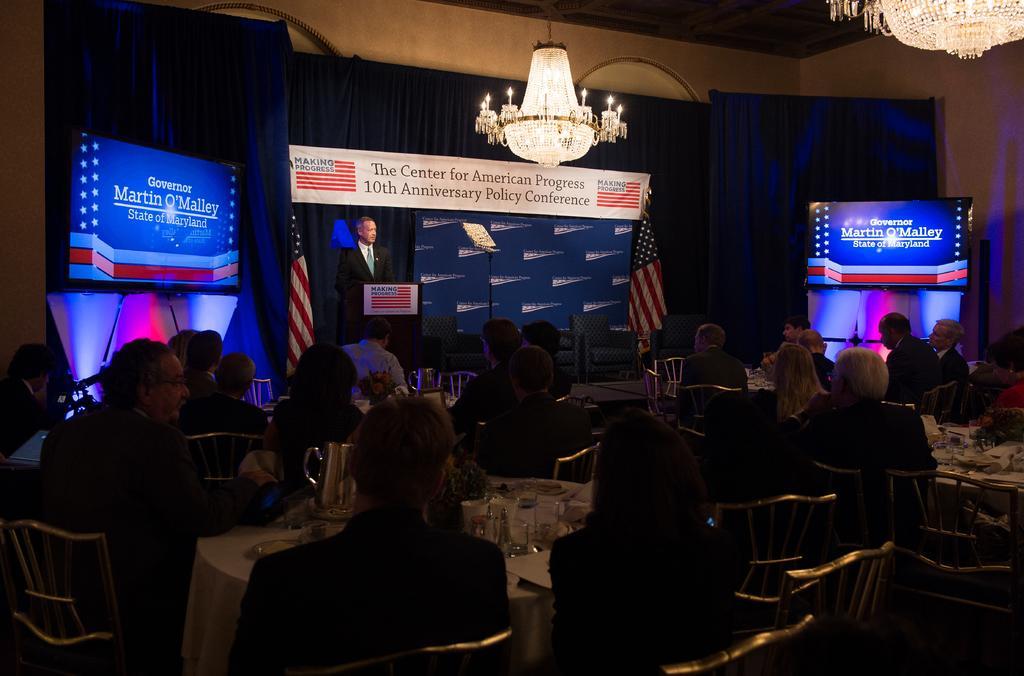In one or two sentences, can you explain what this image depicts? In the picture it looks like some conference, there is a man standing in front of a table in the front and behind him there is a banner and two flags, in front of the banner there are few sofas and many people were sitting around the tables in the front and on the table there are glasses, Mug , plate and other items, there are two screens on the either side of this stage and some names were displaying on those screens and there are blue curtains behind those screens. 